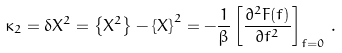<formula> <loc_0><loc_0><loc_500><loc_500>\kappa _ { 2 } = \delta X ^ { 2 } = \left \{ X ^ { 2 } \right \} - \left \{ X \right \} ^ { 2 } = - \frac { 1 } { \beta } \left [ \frac { \partial ^ { 2 } F ( f ) } { \partial f ^ { 2 } } \right ] _ { f = 0 } \, .</formula> 